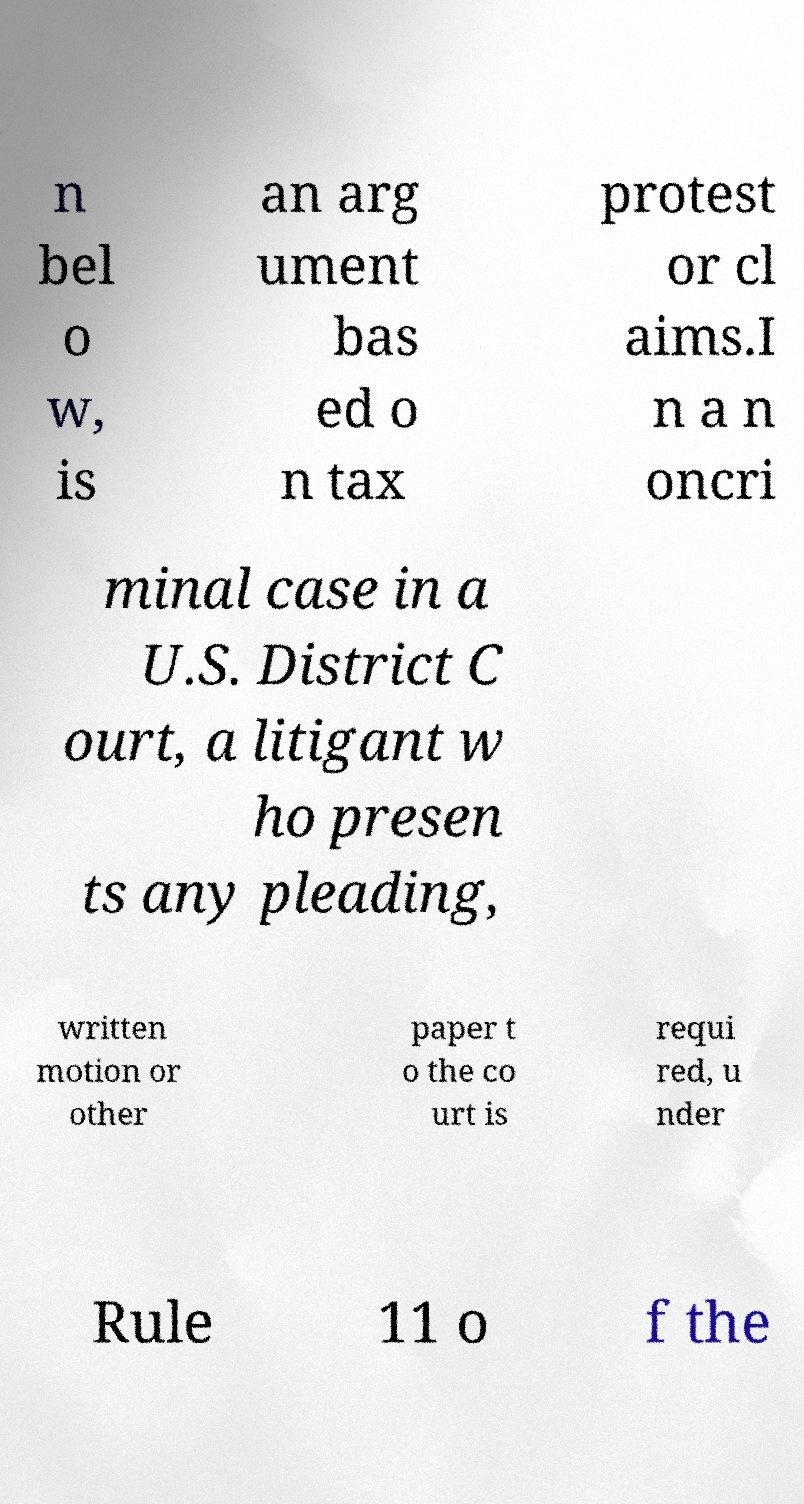Please read and relay the text visible in this image. What does it say? n bel o w, is an arg ument bas ed o n tax protest or cl aims.I n a n oncri minal case in a U.S. District C ourt, a litigant w ho presen ts any pleading, written motion or other paper t o the co urt is requi red, u nder Rule 11 o f the 